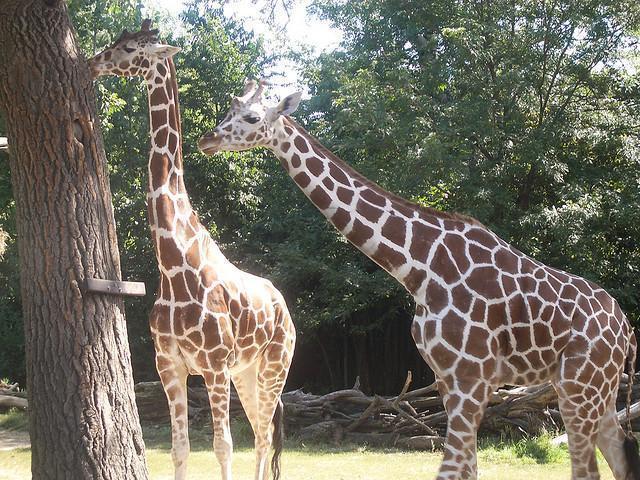How many giraffes are seen?
Give a very brief answer. 2. How many animals are pictured here?
Give a very brief answer. 2. How many giraffes are in the photo?
Give a very brief answer. 2. 